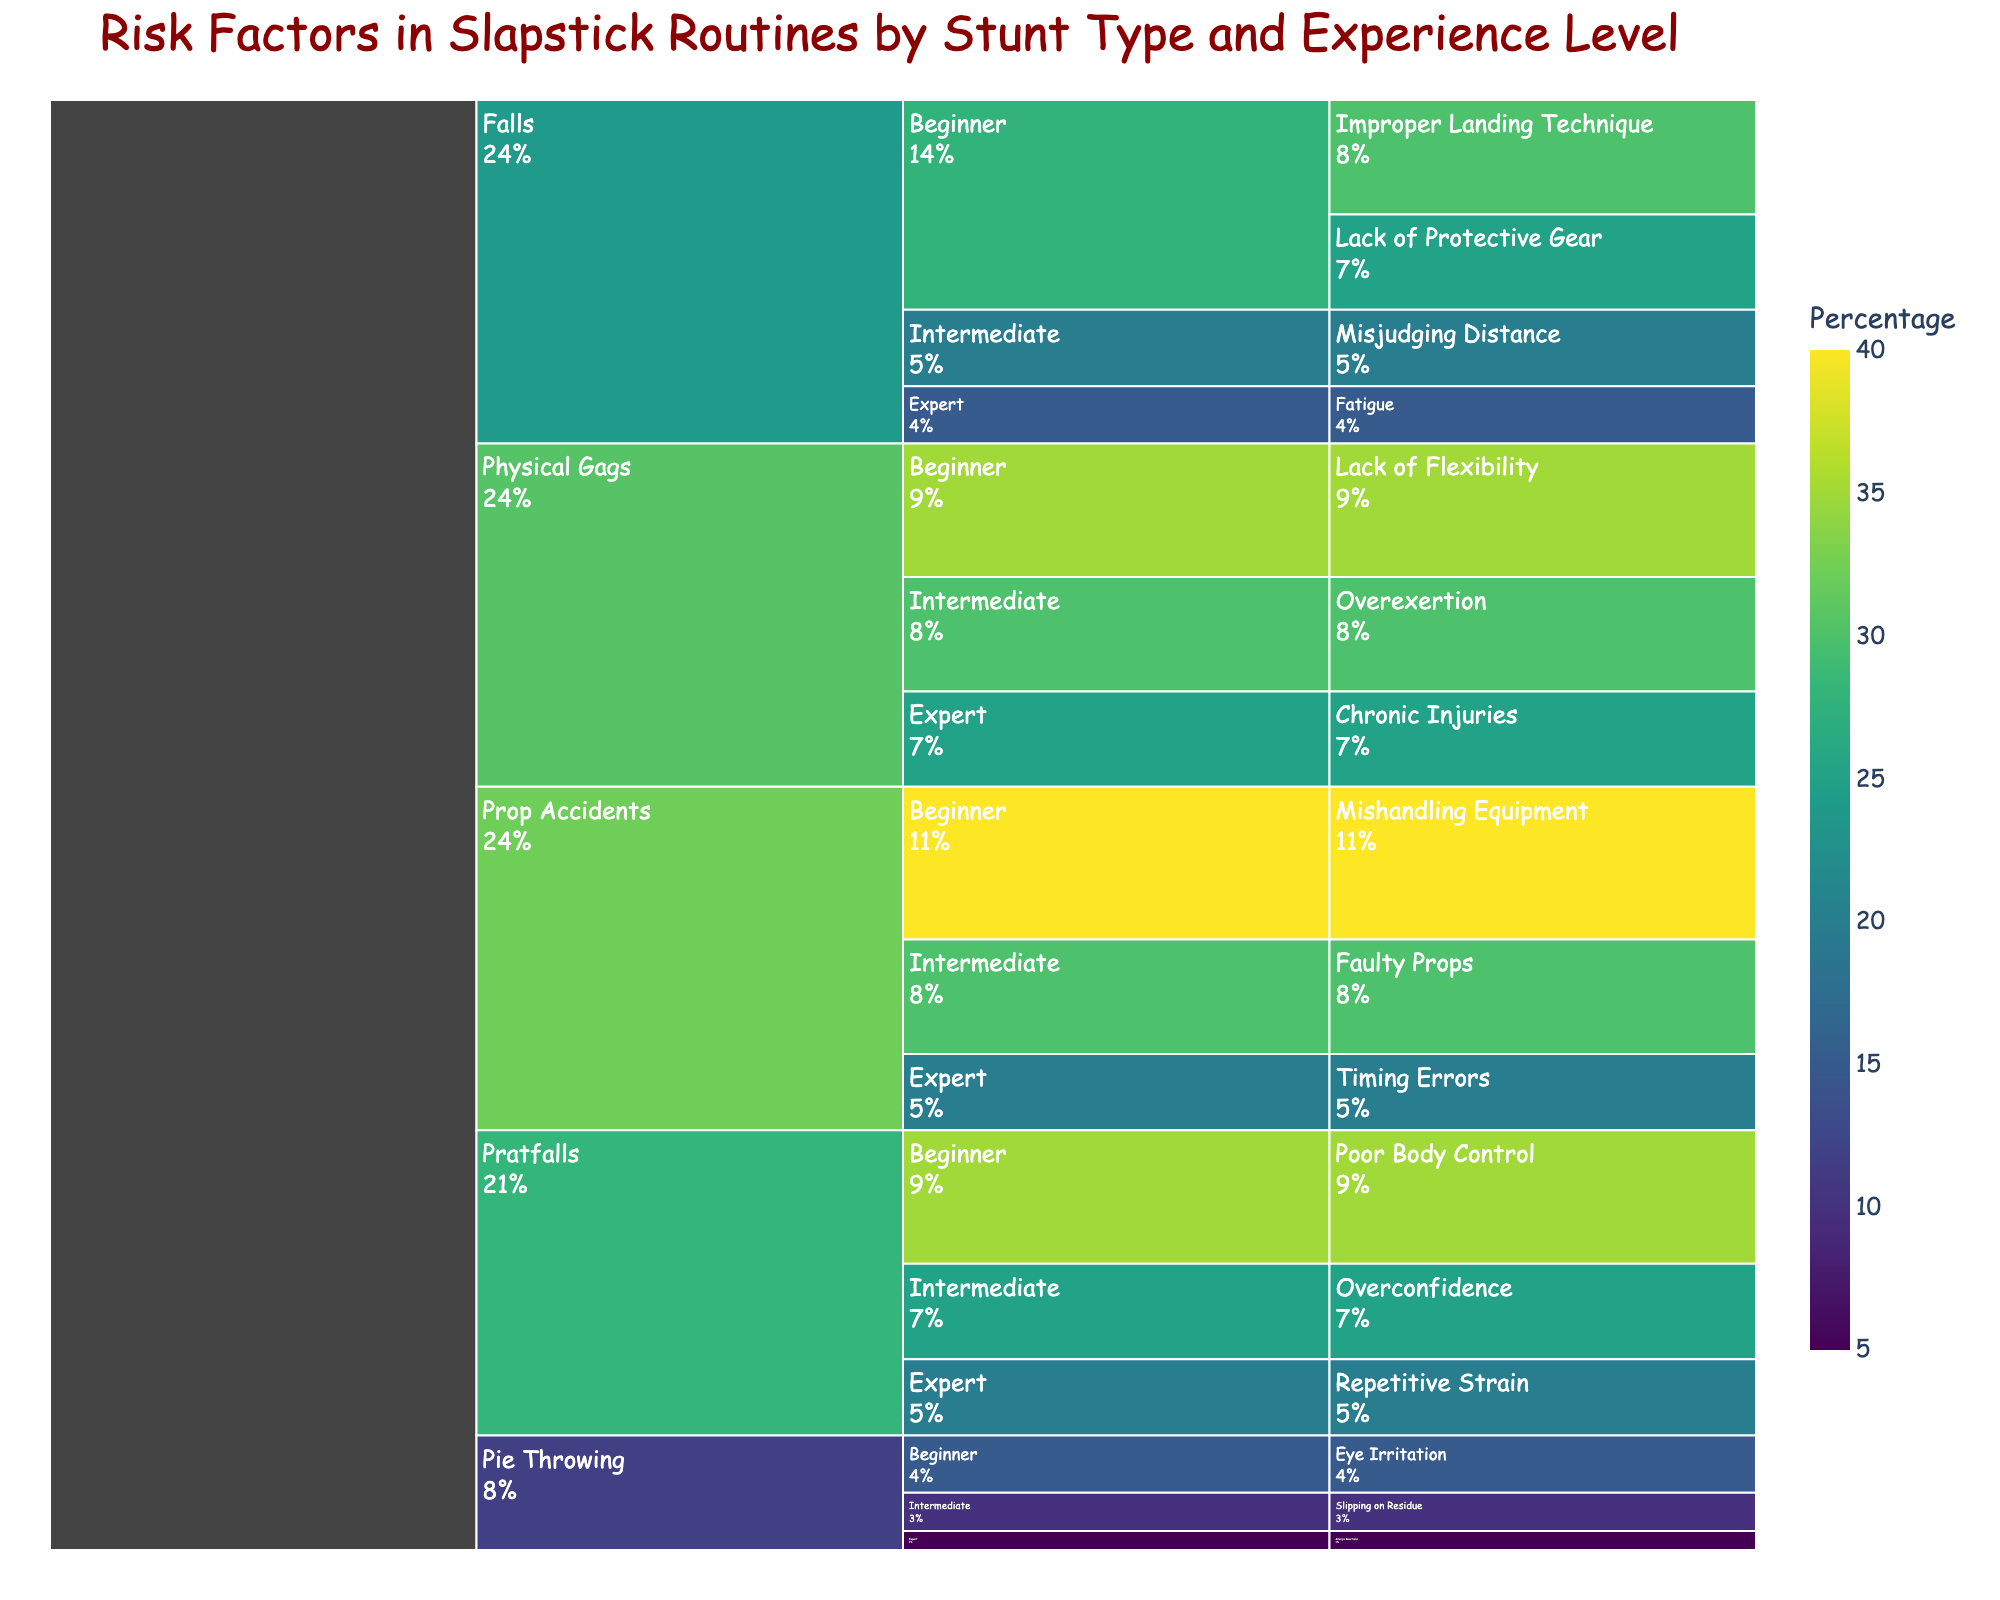What is the title of the chart? The title is typically found at the top of the chart and summarizes what the chart represents. In this case, it is provided directly by the code.
Answer: Risk Factors in Slapstick Routines by Stunt Type and Experience Level Which stunt type has the highest percentage of risk factors for beginners? Look at the beginners' sections under each stunt type and identify the one with the highest percentage. 'Prop Accidents' for beginners has the highest value at 40%.
Answer: Prop Accidents How do the risk factors for intermediate performers compare with those for experts in 'Physical Gags'? Compare the percentages for intermediate and expert levels within the 'Physical Gags' category. 'Overexertion' for intermediates is 30%, and 'Chronic Injuries' for experts is 25%.
Answer: Intermediate performers have higher risk factors What is the most common risk factor for beginners? Check all the beginners' sections and identify the highest percentage across all stunt types. 'Mishandling Equipment' in 'Prop Accidents' for beginners has the highest value at 40%.
Answer: Mishandling Equipment What percentage of risk factor is attributed to 'Eye Irritation' in 'Pie Throwing' for beginners? Find the 'Pie Throwing' section, then look at the beginners' subsection to identify the specific risk factor and its percentage.
Answer: 15% What is the total percentage assigned to 'Falls' for all experience levels? Sum the percentages across all experience levels within the 'Falls' category: 30% (Beginner) + 25% (Beginner) + 20% (Intermediate) + 15% (Expert).
Answer: 90% Which experience level in 'Pratfalls' has the highest risk factor percentage, and what is it? Compare the percentages within the 'Pratfalls' category for each experience level. beginners have the highest risk factor at 35% for 'Poor Body Control'.
Answer: Beginner, 35% How does 'Overexertion' risk in 'Physical Gags' for intermediates compare to 'Lack of Flexibility' for beginners? Find both percentages under 'Physical Gags'. 'Overexertion' for intermediates is 30% and 'Lack of Flexibility' for beginners is 35%.
Answer: Overexertion is 5% less than Lack of Flexibility Which experience level in 'Pie Throwing' has the lowest risk factor percentage, and what is it? Look at the percentages for all experience levels under 'Pie Throwing' and identify the lowest one. 'Allergic Reactions' for experts has the lowest value at 5%.
Answer: Expert, 5% In which stunt type does 'Overconfidence' appear as a risk factor, and for which experience level? Locate the risk factor 'Overconfidence' and note its associated stunt type and experience level. It appears in 'Pratfalls' for Intermediate performers.
Answer: Pratfalls, Intermediate 